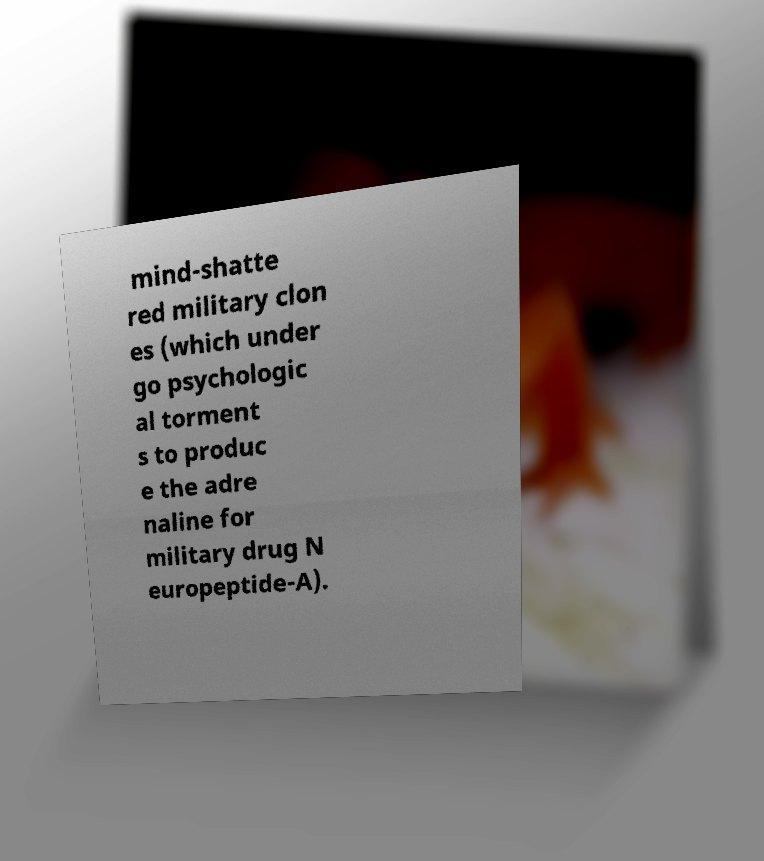What messages or text are displayed in this image? I need them in a readable, typed format. mind-shatte red military clon es (which under go psychologic al torment s to produc e the adre naline for military drug N europeptide-A). 